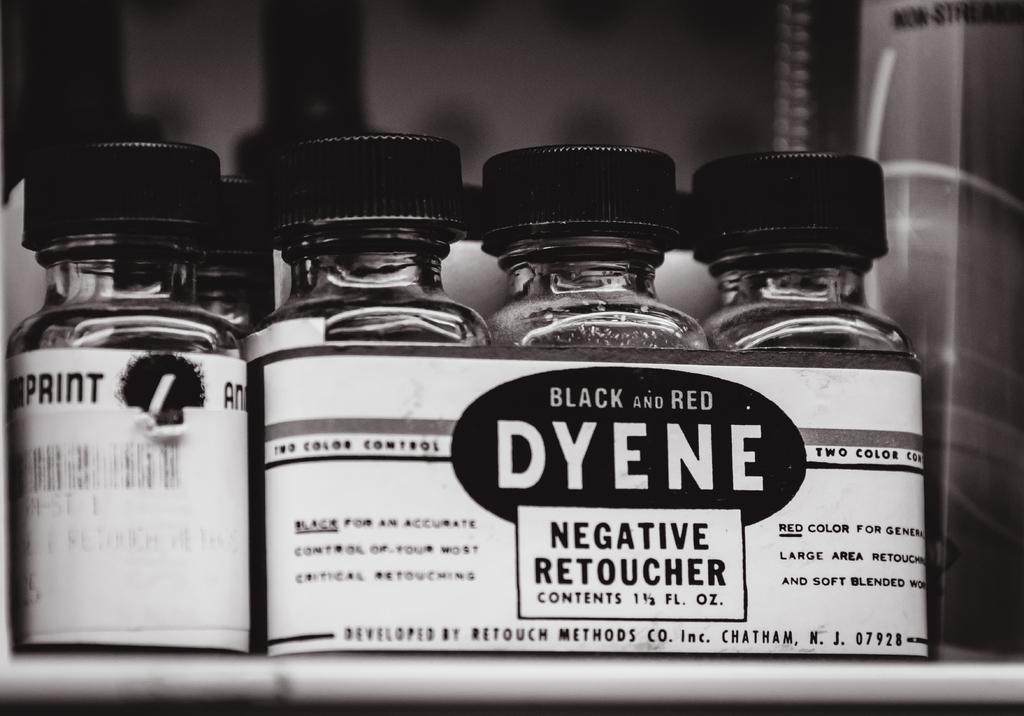<image>
Write a terse but informative summary of the picture. Several bottles of Black and Red Dyene Negative Retoucher are sitting on a shelf. 